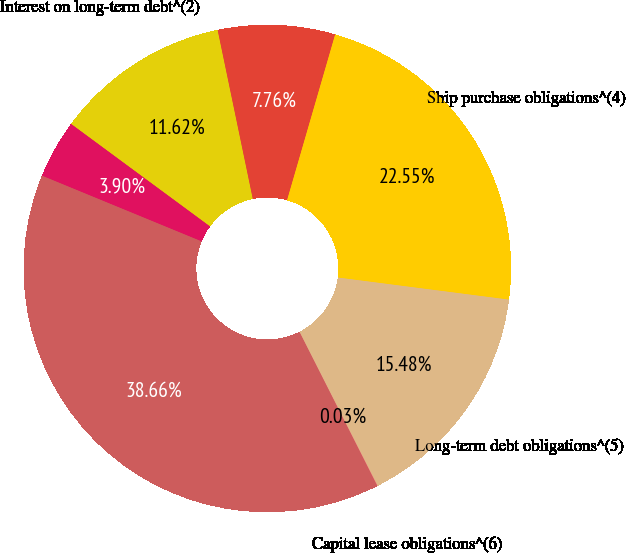<chart> <loc_0><loc_0><loc_500><loc_500><pie_chart><fcel>Operating lease<fcel>Interest on long-term debt^(2)<fcel>Other^(3)<fcel>Ship purchase obligations^(4)<fcel>Long-term debt obligations^(5)<fcel>Capital lease obligations^(6)<fcel>Total<nl><fcel>3.9%<fcel>11.62%<fcel>7.76%<fcel>22.55%<fcel>15.48%<fcel>0.03%<fcel>38.66%<nl></chart> 